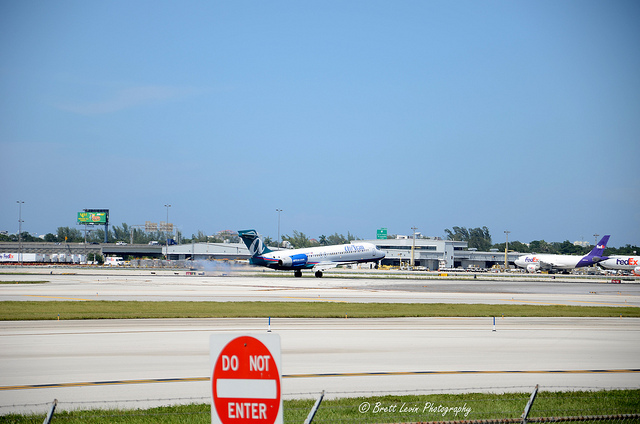What color is the FedEx airplane's tail fin? In the image, the FedEx airplane's tail fin is a distinct purple color, which is part of the company's brand identity. The purple and orange logo can be seen on the tail, which are the standard colors used by FedEx for their branding and marketing. 